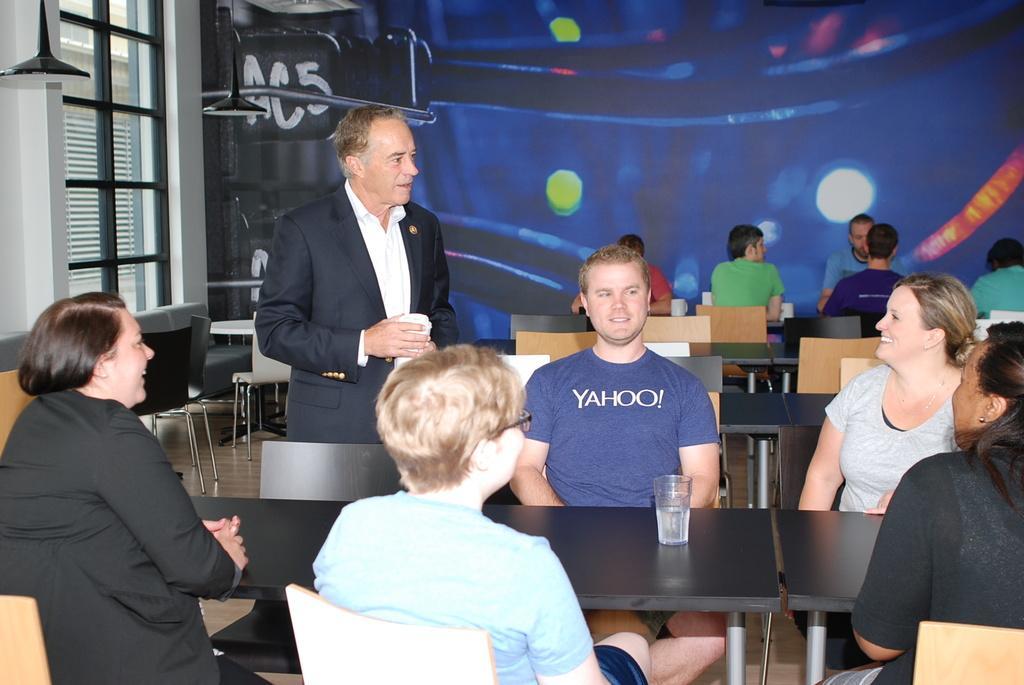Can you describe this image briefly? In this picture we can see people are sitting on the chairs and there is a person standing on the floor. Here we can see tables, chairs, lights, and a window. On the table there is a glass. In the background we can see painting on the wall. 